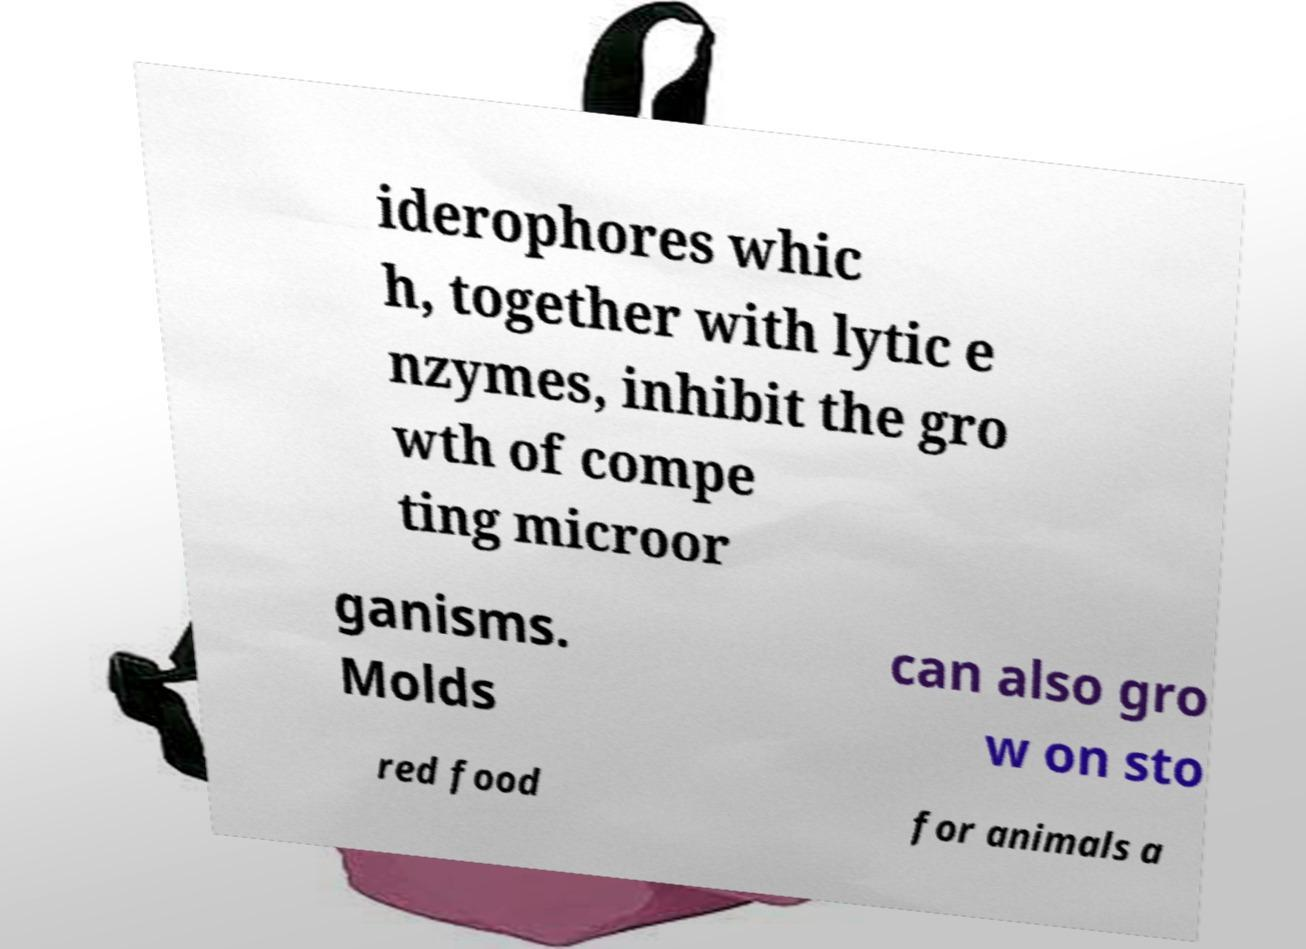I need the written content from this picture converted into text. Can you do that? iderophores whic h, together with lytic e nzymes, inhibit the gro wth of compe ting microor ganisms. Molds can also gro w on sto red food for animals a 